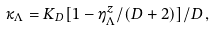Convert formula to latex. <formula><loc_0><loc_0><loc_500><loc_500>\kappa _ { \Lambda } = K _ { D } [ 1 - \eta ^ { z } _ { \Lambda } / ( D + 2 ) ] / D \, ,</formula> 